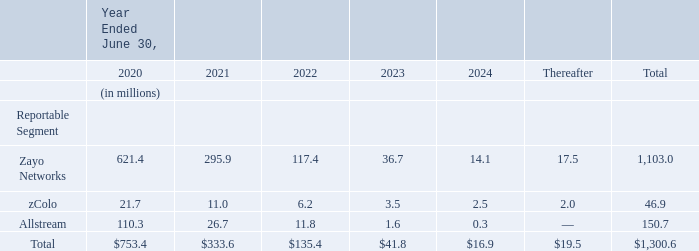Remaining Performance Obligation Associated with Non-Lease Arrangements
A majority of the Company’s revenue is provided over a contract term. When allocating the total contract transaction price to identified performance obligations, a portion of the total transaction price relates to performance obligations that are yet to be satisfied or are partially satisfied as of the end of the reporting period.
In determining the transaction price allocated to remaining performance obligations, the Company does not include non- recurring charges and estimates for usage.
Remaining performance obligations associated with the Company’s contracts reflect recurring charges billed, adjusted to reflect estimates for sales incentives and revenue adjustments.
The table below reflects an estimate of the remaining transaction price of fixed fee, non-lease revenue arrangements to be recognized in the future periods presented. The table below does not include estimated amounts to be recognized in future periods associated with variable usage-based consideration.
What do remaining performance obligations associated with the Company’s contracts reflect? Recurring charges billed, adjusted to reflect estimates for sales incentives and revenue adjustments. What does the table below reflect? The table below reflects an estimate of the remaining transaction price of fixed fee, non-lease revenue arrangements to be recognized in the future periods presented. What does the company not include when determining the transaction price allocated to remaining performance obligations? The company does not include non- recurring charges and estimates for usage. How much remaining transaction price of fixed fee, non-lease revenue arrangements does the company expect to recognize from Zayo Networks and zColo in 2020?
Answer scale should be: million. 621.4+21.7
Answer: 643.1. Which reportable segment had the highest amount in 2024?  36.7 > 3.5 > 1.6
Answer: zayo networks. In which years does the company expect Allstream to have amount of higher than 10 million? 110.3##26.7##11.8
Answer: 2020, 2021, 2022. 